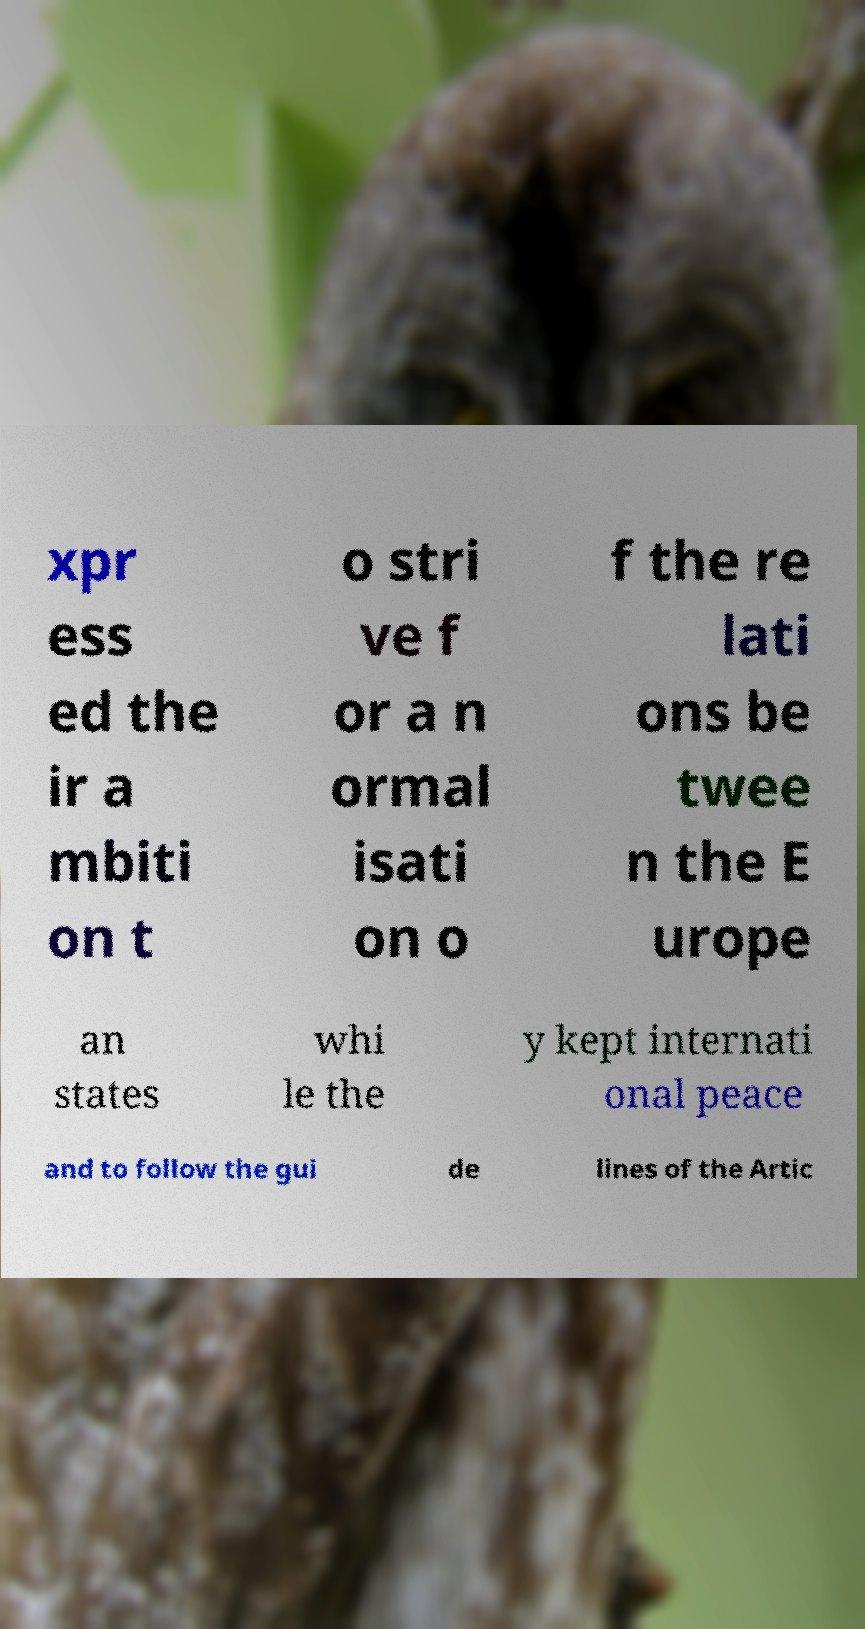For documentation purposes, I need the text within this image transcribed. Could you provide that? xpr ess ed the ir a mbiti on t o stri ve f or a n ormal isati on o f the re lati ons be twee n the E urope an states whi le the y kept internati onal peace and to follow the gui de lines of the Artic 